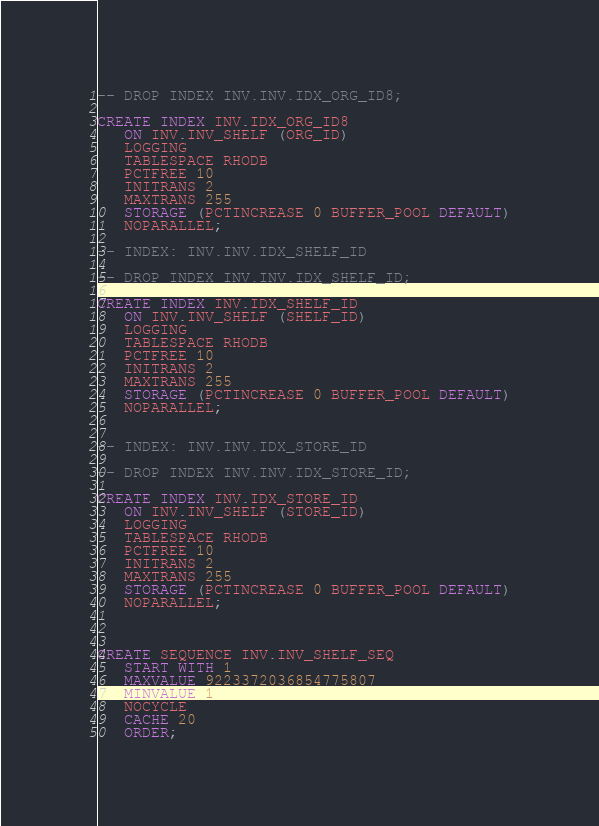<code> <loc_0><loc_0><loc_500><loc_500><_SQL_>
-- DROP INDEX INV.INV.IDX_ORG_ID8;

CREATE INDEX INV.IDX_ORG_ID8
   ON INV.INV_SHELF (ORG_ID)
   LOGGING
   TABLESPACE RHODB
   PCTFREE 10
   INITRANS 2
   MAXTRANS 255
   STORAGE (PCTINCREASE 0 BUFFER_POOL DEFAULT)
   NOPARALLEL;

-- INDEX: INV.INV.IDX_SHELF_ID

-- DROP INDEX INV.INV.IDX_SHELF_ID;

CREATE INDEX INV.IDX_SHELF_ID
   ON INV.INV_SHELF (SHELF_ID)
   LOGGING
   TABLESPACE RHODB
   PCTFREE 10
   INITRANS 2
   MAXTRANS 255
   STORAGE (PCTINCREASE 0 BUFFER_POOL DEFAULT)
   NOPARALLEL;


-- INDEX: INV.INV.IDX_STORE_ID

-- DROP INDEX INV.INV.IDX_STORE_ID;

CREATE INDEX INV.IDX_STORE_ID
   ON INV.INV_SHELF (STORE_ID)
   LOGGING
   TABLESPACE RHODB
   PCTFREE 10
   INITRANS 2
   MAXTRANS 255
   STORAGE (PCTINCREASE 0 BUFFER_POOL DEFAULT)
   NOPARALLEL;



CREATE SEQUENCE INV.INV_SHELF_SEQ
   START WITH 1
   MAXVALUE 9223372036854775807
   MINVALUE 1
   NOCYCLE
   CACHE 20
   ORDER;
</code> 